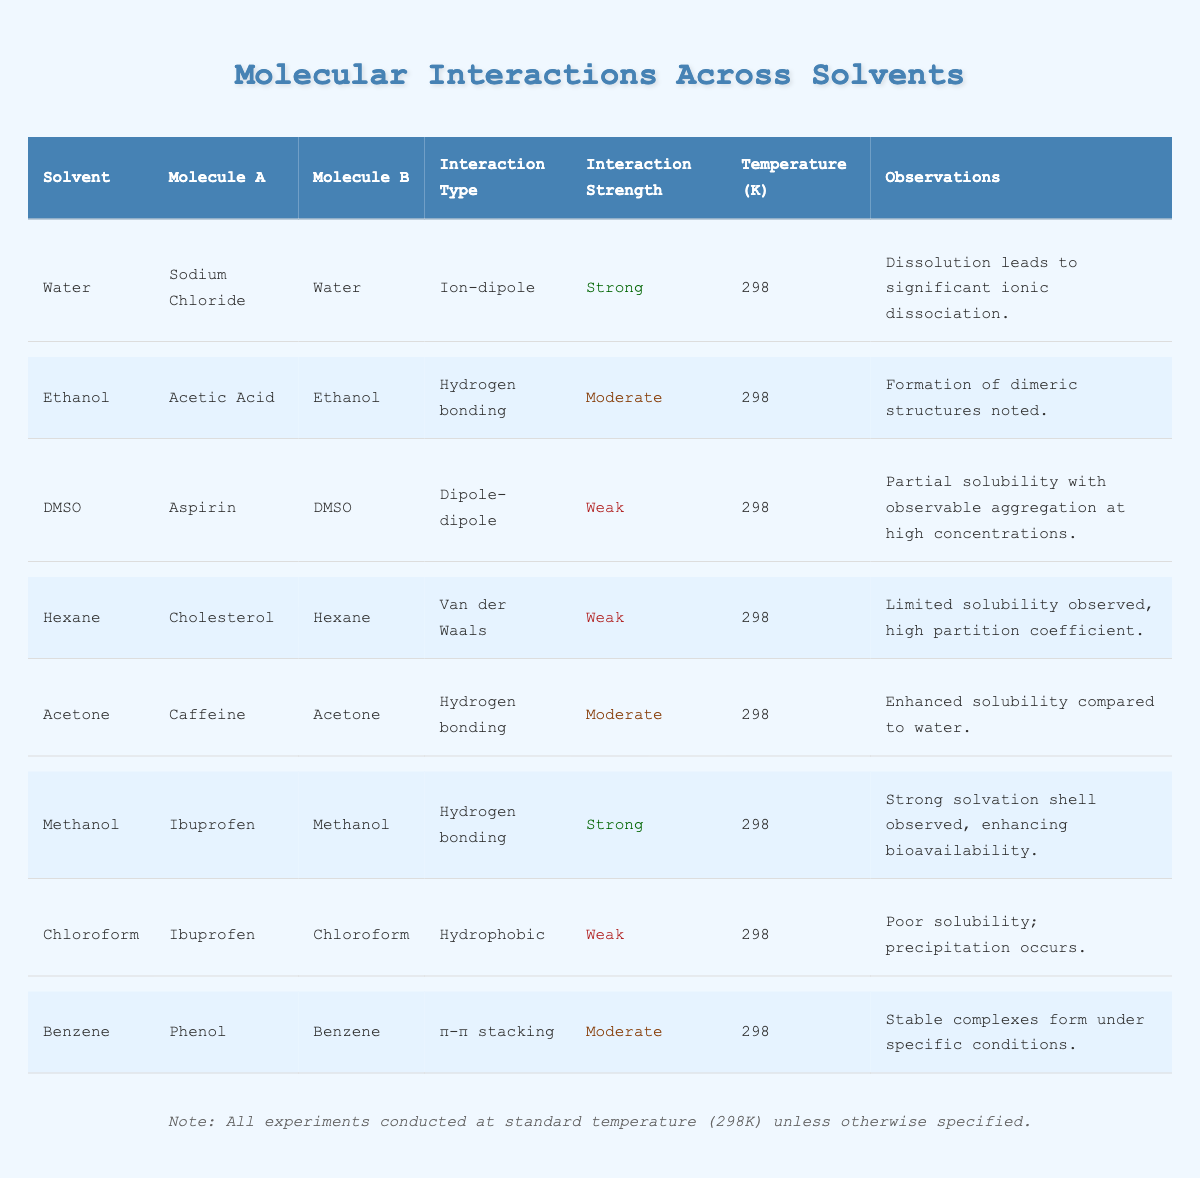What is the interaction type between Sodium Chloride and Water? The table lists the interaction between Sodium Chloride and Water, showing the interaction type as "ion-dipole."
Answer: ion-dipole Which solvent shows a strong interaction with Ibuprofen? According to the table, Methanol is indicated to have a strong interaction with Ibuprofen.
Answer: Methanol How many interactions listed in the table are classified as weak? By counting the rows in the table, there are three interactions with a strength classified as weak (DMSO with Aspirin, Hexane with Cholesterol, and Chloroform with Ibuprofen).
Answer: 3 Is the interaction between Acetic Acid and Ethanol strong? The table states the interaction type is "hydrogen bonding" and its strength is classified as moderate, thus it is not strong.
Answer: No Which solvent has the strongest interaction with Sodium Chloride and what is this interaction type? The table indicates that the interaction between Sodium Chloride and Water is classified as "strong" and the interaction type is "ion-dipole."
Answer: Water, ion-dipole What temperature is noted for all molecular interactions in this table? All interactions are conducted at a consistent temperature, as specified in the table, which is 298 K.
Answer: 298 K Which interaction type is associated with the pairing of Caffeine and Acetone? The interaction type for Caffeine and Acetone is recorded as "hydrogen bonding" in the table.
Answer: Hydrogen bonding If we consider all interaction strengths, what is the total number of moderate interactions? There are three moderate interactions present: Acetic Acid and Ethanol, Caffeine and Acetone, and Phenol and Benzene, making a total of three.
Answer: 3 What are the observations associated with the interaction of Ibuprofen in Methanol? The table notes that a strong solvation shell is observed in Ibuprofen when mixed with Methanol, which enhances bioavailability.
Answer: Strong solvation shell, enhances bioavailability Compare the interaction strengths of Aspirin in DMSO and Ibuprofen in Chloroform. Which has a higher strength? Aspirin in DMSO is classified as weak, while Ibuprofen in Chloroform is also classified as weak; thus, neither has a higher strength.
Answer: Neither How many different molecules are associated with the solvent Ethanol in the table? The table shows that only one molecule, Acetic Acid, is associated with Ethanol, so the count is one.
Answer: 1 